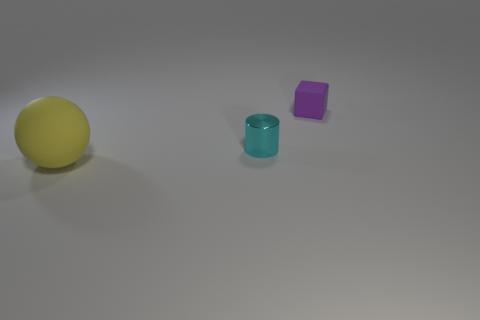How many big things are either blue rubber blocks or purple matte things?
Offer a terse response. 0. Does the small object that is to the left of the small cube have the same material as the yellow ball?
Provide a short and direct response. No. There is a tiny thing in front of the tiny object behind the cyan shiny thing; what is its material?
Your answer should be very brief. Metal. How many yellow rubber objects have the same shape as the tiny metal object?
Provide a short and direct response. 0. There is a thing that is on the right side of the small thing in front of the matte object that is behind the big matte sphere; how big is it?
Your answer should be compact. Small. What number of yellow objects are either spheres or small cylinders?
Make the answer very short. 1. Is the shape of the matte thing that is behind the large object the same as  the tiny metallic object?
Your answer should be compact. No. Is the number of tiny purple things that are on the right side of the purple cube greater than the number of small things?
Give a very brief answer. No. How many purple matte blocks have the same size as the cyan shiny cylinder?
Offer a very short reply. 1. How many things are either cyan things or objects that are left of the cube?
Offer a very short reply. 2. 